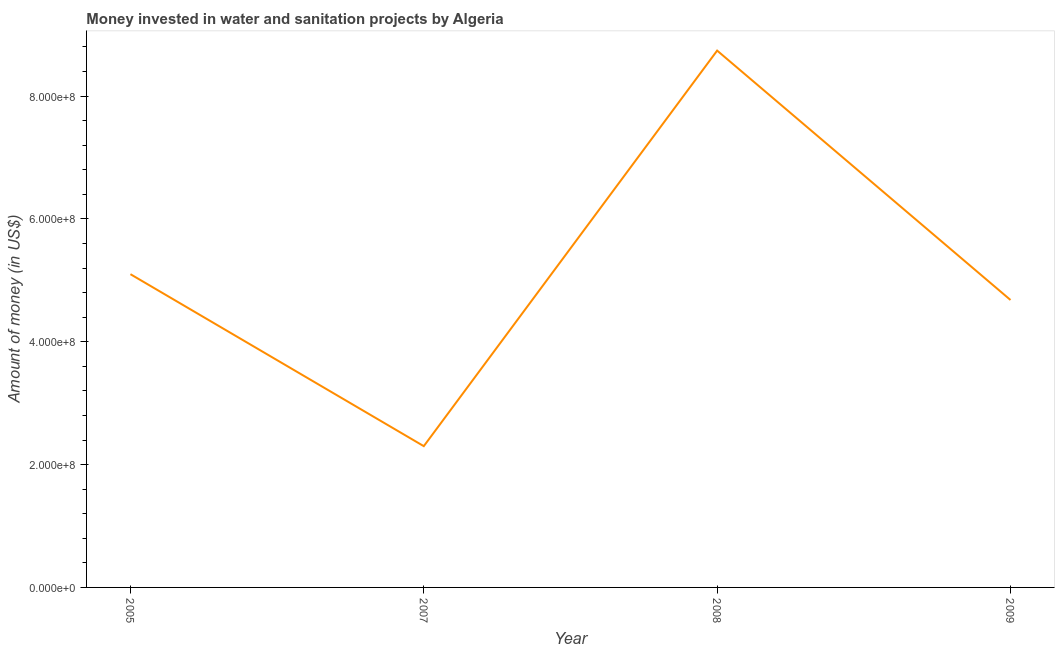What is the investment in 2009?
Offer a very short reply. 4.68e+08. Across all years, what is the maximum investment?
Ensure brevity in your answer.  8.74e+08. Across all years, what is the minimum investment?
Give a very brief answer. 2.30e+08. In which year was the investment minimum?
Make the answer very short. 2007. What is the sum of the investment?
Give a very brief answer. 2.08e+09. What is the difference between the investment in 2005 and 2009?
Your response must be concise. 4.20e+07. What is the average investment per year?
Your answer should be very brief. 5.20e+08. What is the median investment?
Offer a very short reply. 4.89e+08. In how many years, is the investment greater than 640000000 US$?
Offer a very short reply. 1. What is the ratio of the investment in 2005 to that in 2008?
Your answer should be compact. 0.58. What is the difference between the highest and the second highest investment?
Offer a terse response. 3.64e+08. Is the sum of the investment in 2007 and 2009 greater than the maximum investment across all years?
Ensure brevity in your answer.  No. What is the difference between the highest and the lowest investment?
Offer a very short reply. 6.44e+08. In how many years, is the investment greater than the average investment taken over all years?
Give a very brief answer. 1. How many years are there in the graph?
Give a very brief answer. 4. What is the difference between two consecutive major ticks on the Y-axis?
Provide a succinct answer. 2.00e+08. Are the values on the major ticks of Y-axis written in scientific E-notation?
Your answer should be compact. Yes. Does the graph contain grids?
Offer a terse response. No. What is the title of the graph?
Make the answer very short. Money invested in water and sanitation projects by Algeria. What is the label or title of the Y-axis?
Provide a succinct answer. Amount of money (in US$). What is the Amount of money (in US$) in 2005?
Give a very brief answer. 5.10e+08. What is the Amount of money (in US$) of 2007?
Offer a terse response. 2.30e+08. What is the Amount of money (in US$) of 2008?
Offer a very short reply. 8.74e+08. What is the Amount of money (in US$) of 2009?
Your response must be concise. 4.68e+08. What is the difference between the Amount of money (in US$) in 2005 and 2007?
Provide a short and direct response. 2.80e+08. What is the difference between the Amount of money (in US$) in 2005 and 2008?
Keep it short and to the point. -3.64e+08. What is the difference between the Amount of money (in US$) in 2005 and 2009?
Offer a terse response. 4.20e+07. What is the difference between the Amount of money (in US$) in 2007 and 2008?
Give a very brief answer. -6.44e+08. What is the difference between the Amount of money (in US$) in 2007 and 2009?
Offer a terse response. -2.38e+08. What is the difference between the Amount of money (in US$) in 2008 and 2009?
Give a very brief answer. 4.06e+08. What is the ratio of the Amount of money (in US$) in 2005 to that in 2007?
Offer a very short reply. 2.22. What is the ratio of the Amount of money (in US$) in 2005 to that in 2008?
Provide a short and direct response. 0.58. What is the ratio of the Amount of money (in US$) in 2005 to that in 2009?
Your answer should be compact. 1.09. What is the ratio of the Amount of money (in US$) in 2007 to that in 2008?
Ensure brevity in your answer.  0.26. What is the ratio of the Amount of money (in US$) in 2007 to that in 2009?
Ensure brevity in your answer.  0.49. What is the ratio of the Amount of money (in US$) in 2008 to that in 2009?
Make the answer very short. 1.87. 